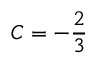Convert formula to latex. <formula><loc_0><loc_0><loc_500><loc_500>C = - { \frac { 2 } { 3 } }</formula> 